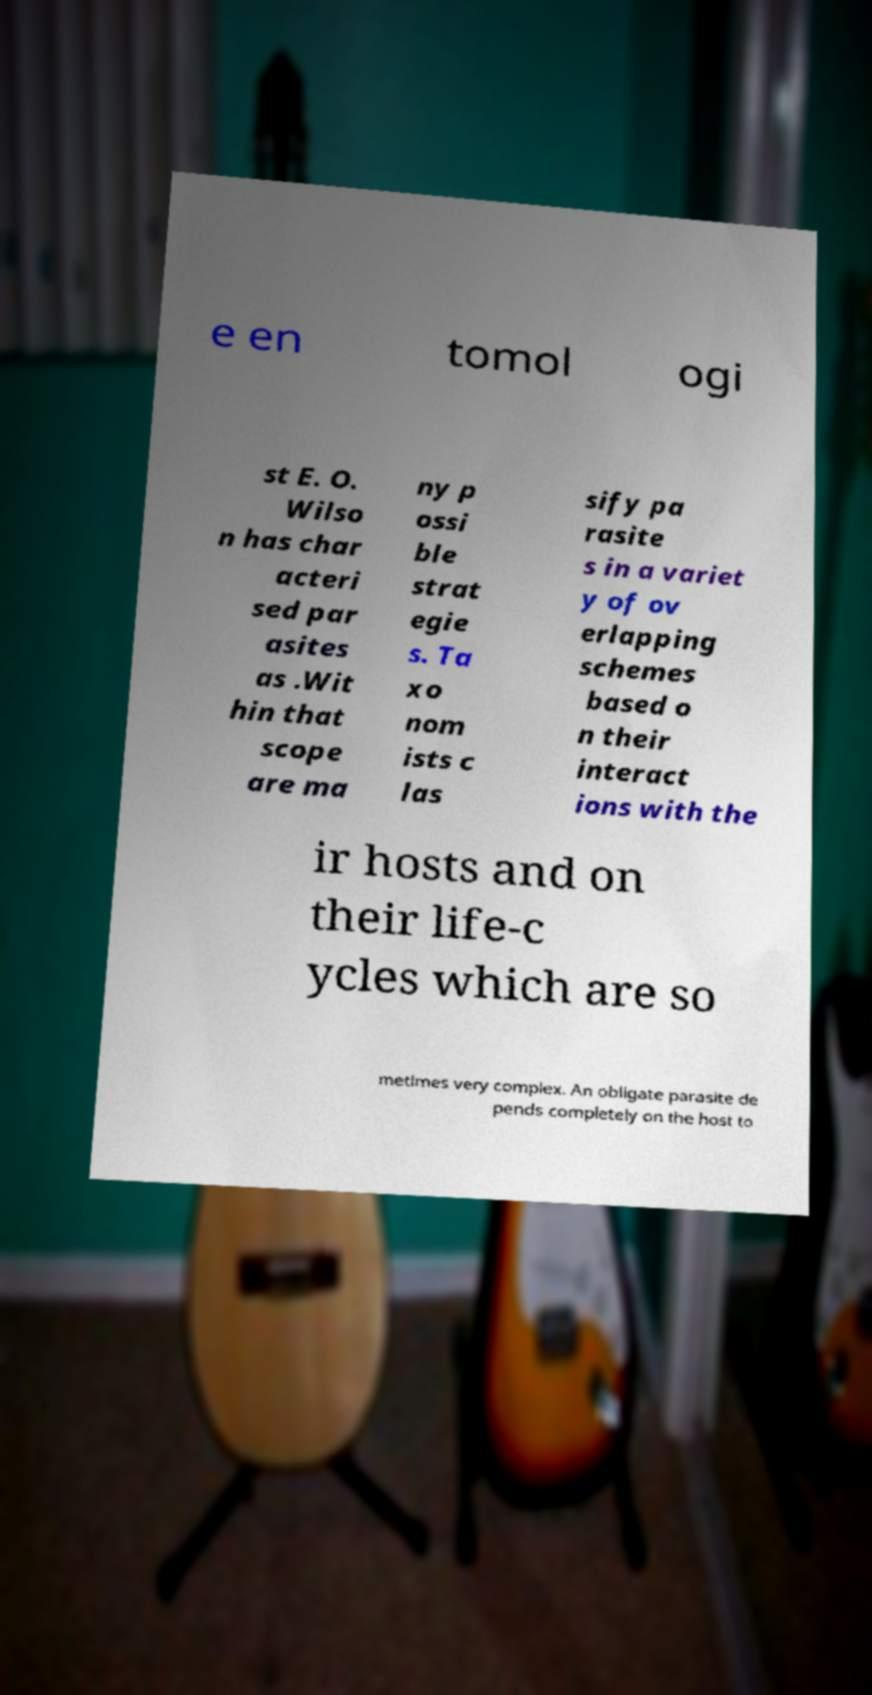Can you read and provide the text displayed in the image?This photo seems to have some interesting text. Can you extract and type it out for me? e en tomol ogi st E. O. Wilso n has char acteri sed par asites as .Wit hin that scope are ma ny p ossi ble strat egie s. Ta xo nom ists c las sify pa rasite s in a variet y of ov erlapping schemes based o n their interact ions with the ir hosts and on their life-c ycles which are so metimes very complex. An obligate parasite de pends completely on the host to 